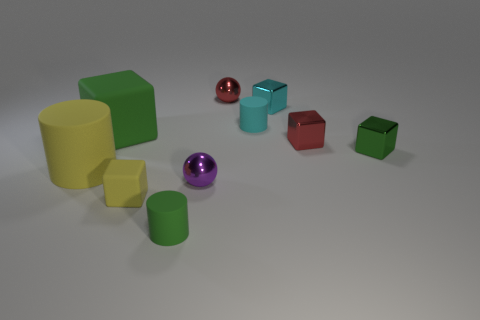Subtract all yellow blocks. How many blocks are left? 4 Subtract all big green matte cubes. How many cubes are left? 4 Subtract all brown cubes. Subtract all brown cylinders. How many cubes are left? 5 Subtract all balls. How many objects are left? 8 Add 4 small purple metal objects. How many small purple metal objects are left? 5 Add 3 yellow metal blocks. How many yellow metal blocks exist? 3 Subtract 0 red cylinders. How many objects are left? 10 Subtract all green cylinders. Subtract all small cyan cylinders. How many objects are left? 8 